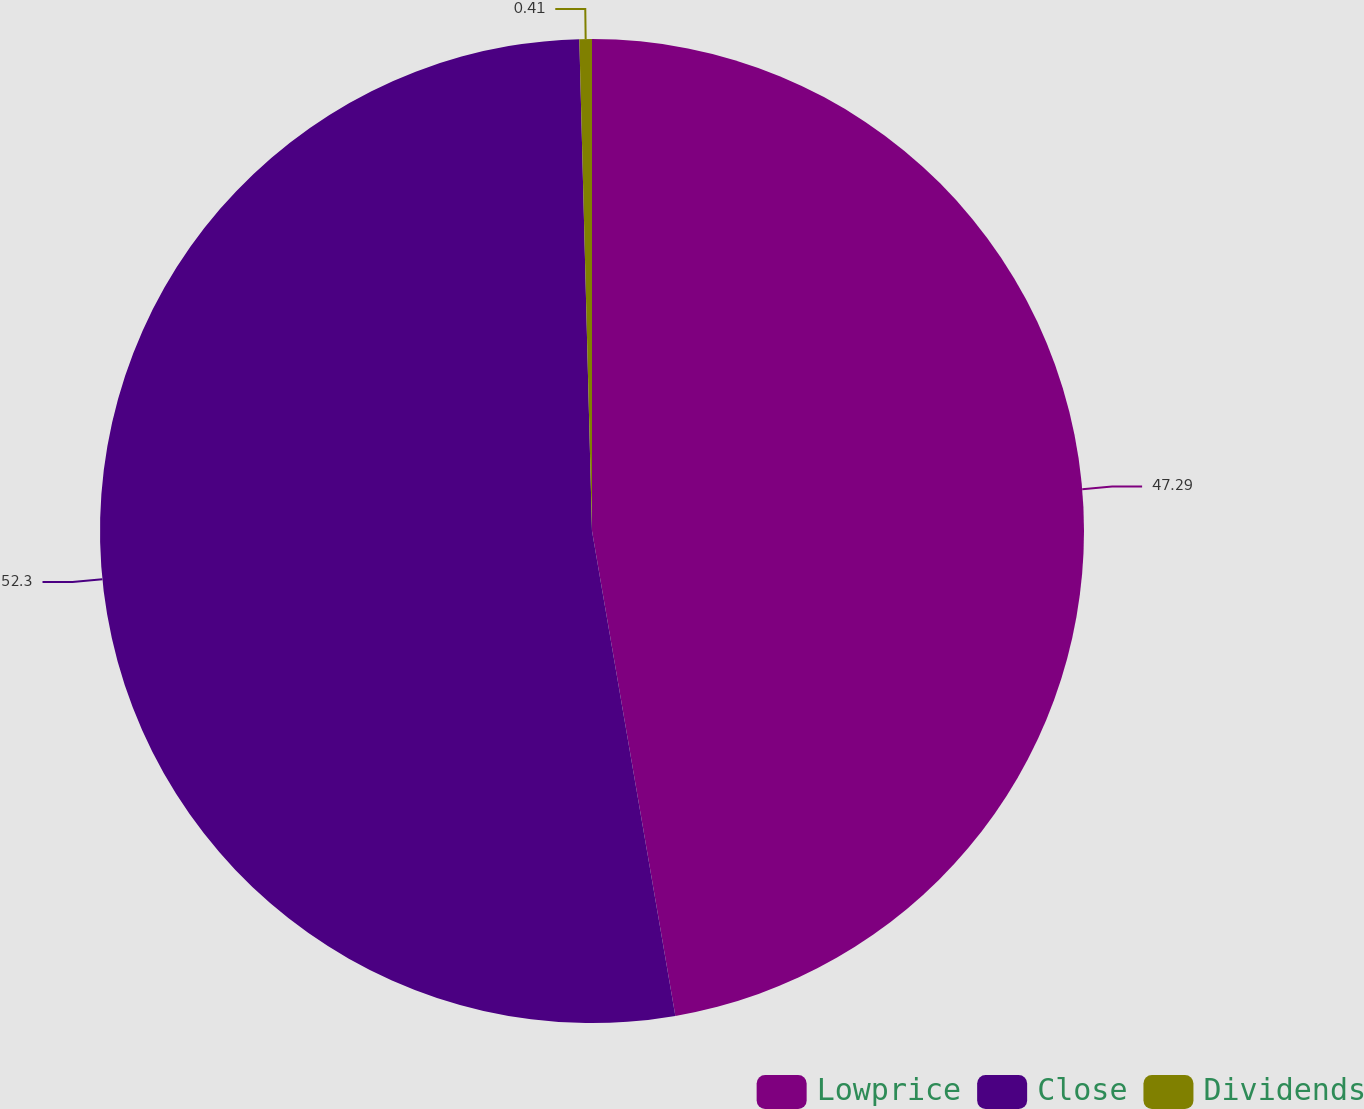Convert chart to OTSL. <chart><loc_0><loc_0><loc_500><loc_500><pie_chart><fcel>Lowprice<fcel>Close<fcel>Dividends<nl><fcel>47.29%<fcel>52.3%<fcel>0.41%<nl></chart> 